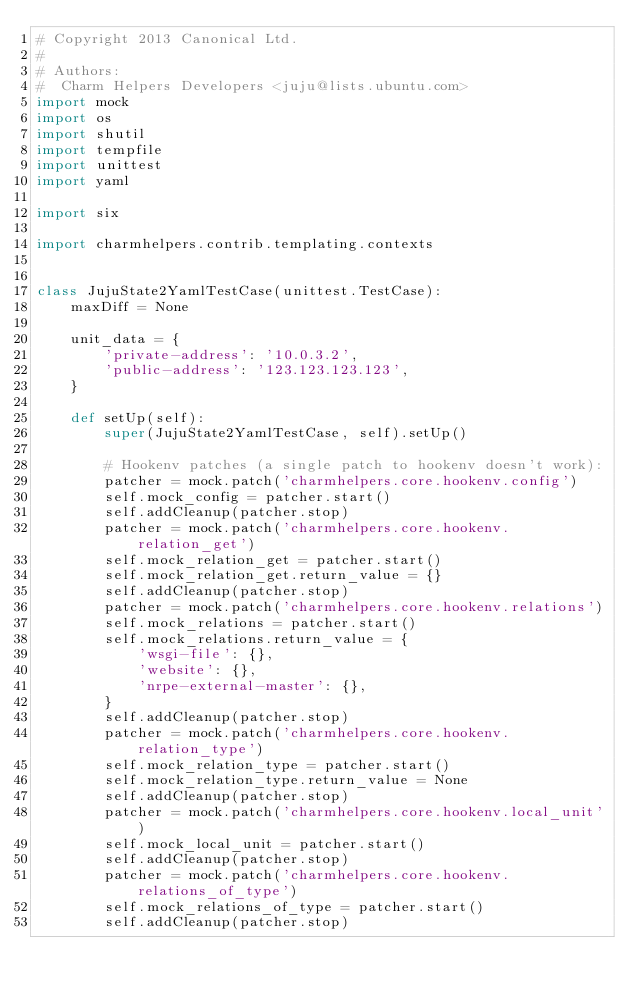<code> <loc_0><loc_0><loc_500><loc_500><_Python_># Copyright 2013 Canonical Ltd.
#
# Authors:
#  Charm Helpers Developers <juju@lists.ubuntu.com>
import mock
import os
import shutil
import tempfile
import unittest
import yaml

import six

import charmhelpers.contrib.templating.contexts


class JujuState2YamlTestCase(unittest.TestCase):
    maxDiff = None

    unit_data = {
        'private-address': '10.0.3.2',
        'public-address': '123.123.123.123',
    }

    def setUp(self):
        super(JujuState2YamlTestCase, self).setUp()

        # Hookenv patches (a single patch to hookenv doesn't work):
        patcher = mock.patch('charmhelpers.core.hookenv.config')
        self.mock_config = patcher.start()
        self.addCleanup(patcher.stop)
        patcher = mock.patch('charmhelpers.core.hookenv.relation_get')
        self.mock_relation_get = patcher.start()
        self.mock_relation_get.return_value = {}
        self.addCleanup(patcher.stop)
        patcher = mock.patch('charmhelpers.core.hookenv.relations')
        self.mock_relations = patcher.start()
        self.mock_relations.return_value = {
            'wsgi-file': {},
            'website': {},
            'nrpe-external-master': {},
        }
        self.addCleanup(patcher.stop)
        patcher = mock.patch('charmhelpers.core.hookenv.relation_type')
        self.mock_relation_type = patcher.start()
        self.mock_relation_type.return_value = None
        self.addCleanup(patcher.stop)
        patcher = mock.patch('charmhelpers.core.hookenv.local_unit')
        self.mock_local_unit = patcher.start()
        self.addCleanup(patcher.stop)
        patcher = mock.patch('charmhelpers.core.hookenv.relations_of_type')
        self.mock_relations_of_type = patcher.start()
        self.addCleanup(patcher.stop)</code> 